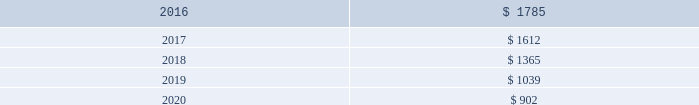Comcast corporation finite-lived intangible assets estimated amortization expense of finite-lived intangible assets ( in millions ) .
Finite-lived intangible assets are subject to amortization and consist primarily of customer relationships acquired in business combinations , software , cable franchise renewal costs , contractual operating rights and intellectual property rights .
Our finite-lived intangible assets are amortized primarily on a straight-line basis over their estimated useful life or the term of the associated agreement .
We capitalize direct development costs associated with internal-use software , including external direct costs of material and services and payroll costs for employees devoting time to these software projects .
We also capitalize costs associated with the purchase of software licenses .
We include these costs in other intangible assets and generally amortize them on a straight-line basis over a period not to exceed five years .
We expense maintenance and training costs , as well as costs incurred during the preliminary stage of a project , as they are incurred .
We capitalize initial operating system software costs and amortize them over the life of the associated hardware .
We evaluate the recoverability of our finite-lived intangible assets whenever events or substantive changes in circumstances indicate that the carrying amount may not be recoverable .
The evaluation is based on the cash flows generated by the underlying asset groups , including estimated future operating results , trends or other determinants of fair value .
If the total of the expected future undiscounted cash flows were less than the carry- ing amount of the asset group , we would recognize an impairment charge to the extent the carrying amount of the asset group exceeded its estimated fair value .
Unless presented separately , the impairment charge is included as a component of amortization expense .
97 comcast 2015 annual report on form 10-k .
What was the ratio of the comcast corporation finite-lived intangible assets in 2016 to 2017? 
Computations: (1785 / 1612)
Answer: 1.10732. 